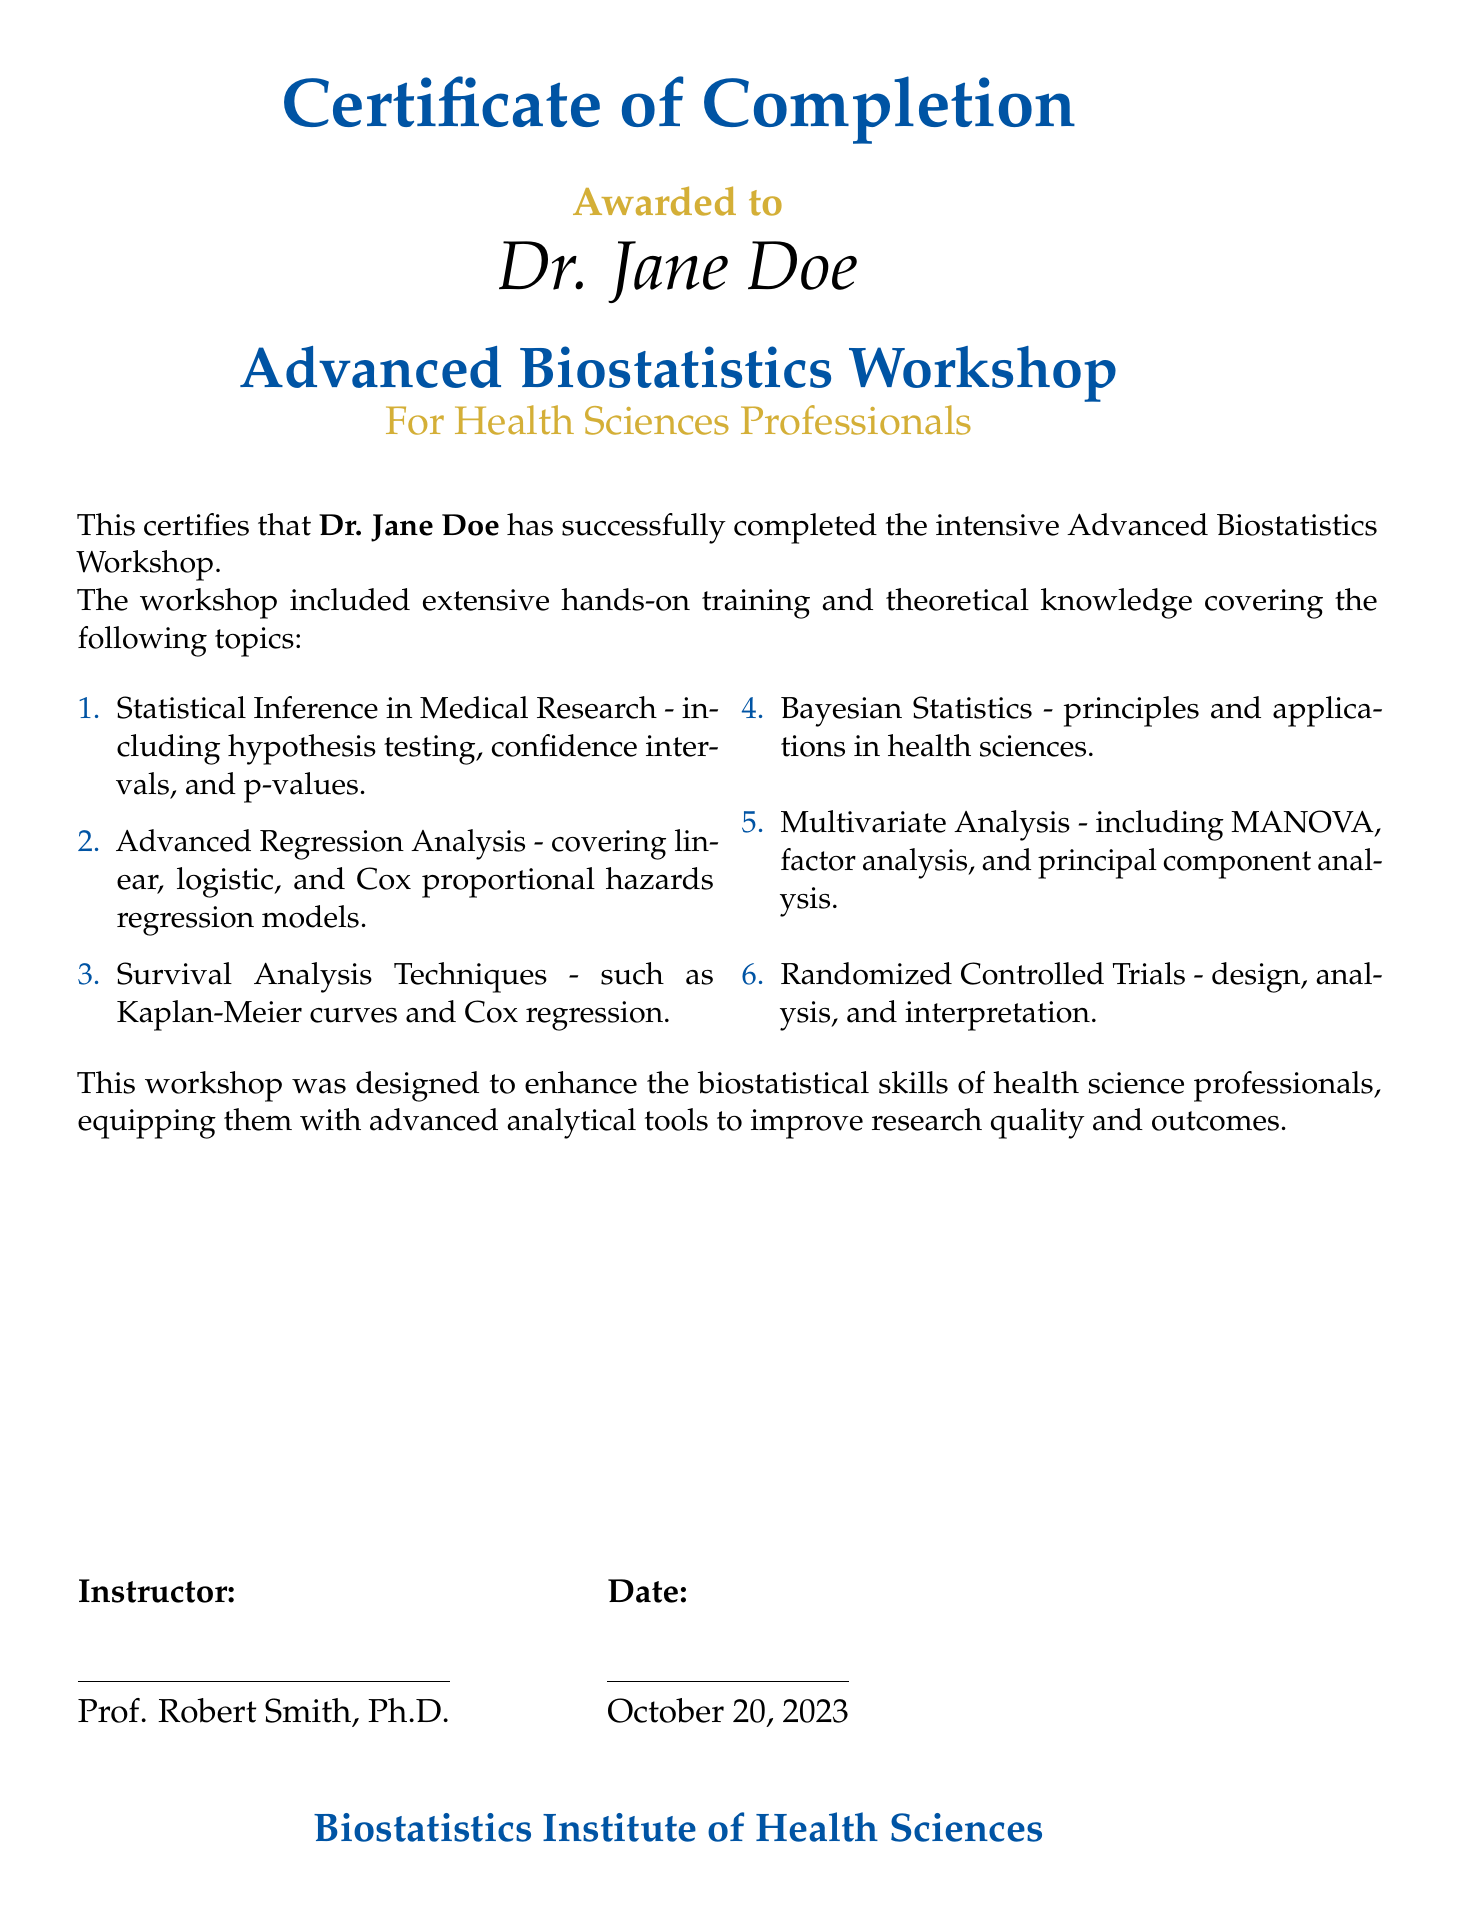What is the name of the awarded individual? The name of the awarded individual is specifically mentioned in the document as Dr. Jane Doe.
Answer: Dr. Jane Doe What is the title of the workshop? The title of the workshop is highlighted in the document as the Advanced Biostatistics Workshop.
Answer: Advanced Biostatistics Workshop Who was the instructor of the workshop? The document lists the instructor's name, which is Prof. Robert Smith, Ph.D.
Answer: Prof. Robert Smith, Ph.D On what date was the workshop completed? The date on which the workshop was completed is given as October 20, 2023.
Answer: October 20, 2023 What is one of the topics covered in the workshop? Various topics are listed, including statistical inference in medical research, which is one of the topics.
Answer: Statistical Inference in Medical Research How many topics are covered in the workshop? The total number of topics listed is six, as mentioned in the enumeration.
Answer: Six What is the color scheme used for the certificate title? The title is indicated to be in medical blue, as highlighted in the document.
Answer: Medical blue What organization issued the certificate? The organization that issued the certificate is stated as the Biostatistics Institute of Health Sciences.
Answer: Biostatistics Institute of Health Sciences 